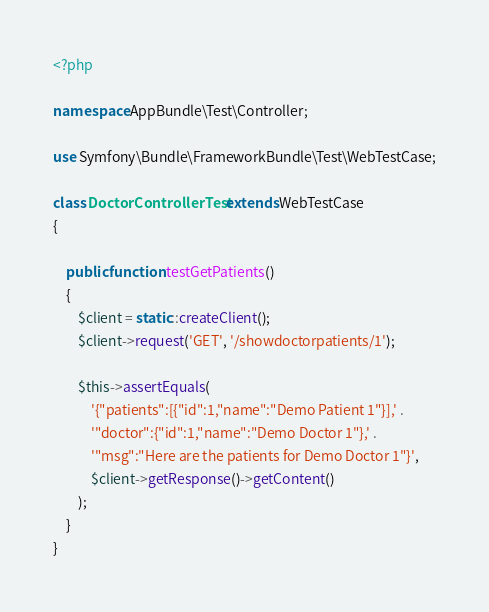Convert code to text. <code><loc_0><loc_0><loc_500><loc_500><_PHP_><?php

namespace AppBundle\Test\Controller;

use Symfony\Bundle\FrameworkBundle\Test\WebTestCase;

class DoctorControllerTest extends WebTestCase
{

    public function testGetPatients()
    {
        $client = static::createClient();
        $client->request('GET', '/showdoctorpatients/1');

        $this->assertEquals(
            '{"patients":[{"id":1,"name":"Demo Patient 1"}],' .
            '"doctor":{"id":1,"name":"Demo Doctor 1"},' .
            '"msg":"Here are the patients for Demo Doctor 1"}',
            $client->getResponse()->getContent()
        );
    }
}
</code> 